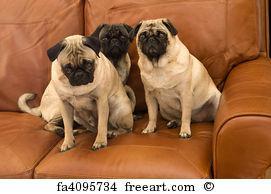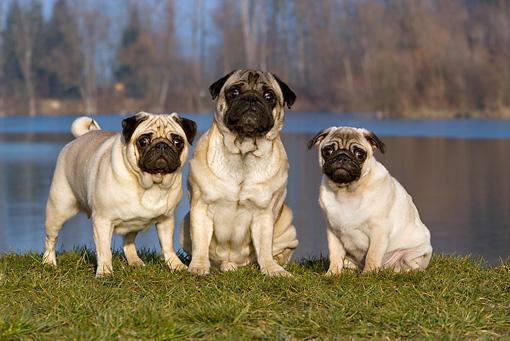The first image is the image on the left, the second image is the image on the right. Evaluate the accuracy of this statement regarding the images: "The right image contains exactly three pug dogs.". Is it true? Answer yes or no. Yes. The first image is the image on the left, the second image is the image on the right. For the images shown, is this caption "There are at most two dogs." true? Answer yes or no. No. 